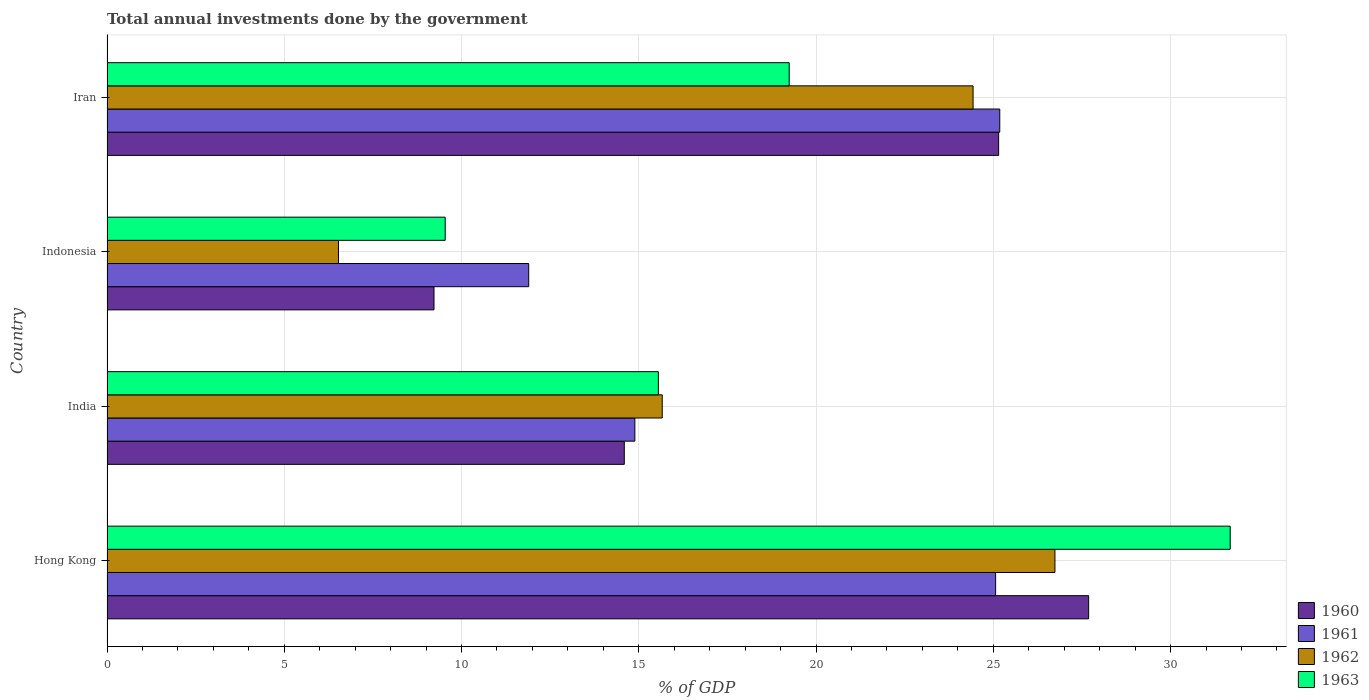How many different coloured bars are there?
Offer a very short reply. 4. How many bars are there on the 4th tick from the bottom?
Your answer should be very brief. 4. What is the label of the 1st group of bars from the top?
Offer a very short reply. Iran. In how many cases, is the number of bars for a given country not equal to the number of legend labels?
Your response must be concise. 0. What is the total annual investments done by the government in 1960 in Hong Kong?
Ensure brevity in your answer.  27.69. Across all countries, what is the maximum total annual investments done by the government in 1963?
Provide a succinct answer. 31.68. Across all countries, what is the minimum total annual investments done by the government in 1963?
Provide a succinct answer. 9.54. In which country was the total annual investments done by the government in 1960 maximum?
Your answer should be very brief. Hong Kong. What is the total total annual investments done by the government in 1961 in the graph?
Provide a short and direct response. 77.03. What is the difference between the total annual investments done by the government in 1963 in Indonesia and that in Iran?
Offer a terse response. -9.7. What is the difference between the total annual investments done by the government in 1963 in India and the total annual investments done by the government in 1961 in Indonesia?
Keep it short and to the point. 3.66. What is the average total annual investments done by the government in 1960 per country?
Provide a short and direct response. 19.16. What is the difference between the total annual investments done by the government in 1961 and total annual investments done by the government in 1962 in Hong Kong?
Make the answer very short. -1.67. In how many countries, is the total annual investments done by the government in 1963 greater than 3 %?
Make the answer very short. 4. What is the ratio of the total annual investments done by the government in 1963 in India to that in Iran?
Provide a short and direct response. 0.81. Is the total annual investments done by the government in 1960 in Hong Kong less than that in Iran?
Offer a terse response. No. Is the difference between the total annual investments done by the government in 1961 in Hong Kong and India greater than the difference between the total annual investments done by the government in 1962 in Hong Kong and India?
Make the answer very short. No. What is the difference between the highest and the second highest total annual investments done by the government in 1963?
Make the answer very short. 12.44. What is the difference between the highest and the lowest total annual investments done by the government in 1963?
Your answer should be compact. 22.14. Is it the case that in every country, the sum of the total annual investments done by the government in 1960 and total annual investments done by the government in 1961 is greater than the sum of total annual investments done by the government in 1963 and total annual investments done by the government in 1962?
Provide a short and direct response. No. What does the 3rd bar from the bottom in Indonesia represents?
Your response must be concise. 1962. Are all the bars in the graph horizontal?
Provide a succinct answer. Yes. How many countries are there in the graph?
Your answer should be very brief. 4. Are the values on the major ticks of X-axis written in scientific E-notation?
Provide a succinct answer. No. Does the graph contain any zero values?
Your answer should be very brief. No. Does the graph contain grids?
Offer a very short reply. Yes. How are the legend labels stacked?
Keep it short and to the point. Vertical. What is the title of the graph?
Provide a succinct answer. Total annual investments done by the government. Does "2000" appear as one of the legend labels in the graph?
Keep it short and to the point. No. What is the label or title of the X-axis?
Your answer should be very brief. % of GDP. What is the label or title of the Y-axis?
Make the answer very short. Country. What is the % of GDP in 1960 in Hong Kong?
Your answer should be very brief. 27.69. What is the % of GDP of 1961 in Hong Kong?
Make the answer very short. 25.06. What is the % of GDP in 1962 in Hong Kong?
Give a very brief answer. 26.74. What is the % of GDP of 1963 in Hong Kong?
Provide a succinct answer. 31.68. What is the % of GDP of 1960 in India?
Ensure brevity in your answer.  14.59. What is the % of GDP of 1961 in India?
Your answer should be compact. 14.89. What is the % of GDP of 1962 in India?
Offer a very short reply. 15.66. What is the % of GDP of 1963 in India?
Your response must be concise. 15.55. What is the % of GDP in 1960 in Indonesia?
Ensure brevity in your answer.  9.22. What is the % of GDP of 1961 in Indonesia?
Your answer should be very brief. 11.9. What is the % of GDP of 1962 in Indonesia?
Keep it short and to the point. 6.53. What is the % of GDP in 1963 in Indonesia?
Your answer should be very brief. 9.54. What is the % of GDP of 1960 in Iran?
Your response must be concise. 25.15. What is the % of GDP in 1961 in Iran?
Your response must be concise. 25.18. What is the % of GDP of 1962 in Iran?
Keep it short and to the point. 24.43. What is the % of GDP of 1963 in Iran?
Keep it short and to the point. 19.24. Across all countries, what is the maximum % of GDP in 1960?
Offer a very short reply. 27.69. Across all countries, what is the maximum % of GDP of 1961?
Offer a very short reply. 25.18. Across all countries, what is the maximum % of GDP of 1962?
Provide a short and direct response. 26.74. Across all countries, what is the maximum % of GDP of 1963?
Offer a terse response. 31.68. Across all countries, what is the minimum % of GDP of 1960?
Ensure brevity in your answer.  9.22. Across all countries, what is the minimum % of GDP of 1961?
Make the answer very short. 11.9. Across all countries, what is the minimum % of GDP in 1962?
Provide a succinct answer. 6.53. Across all countries, what is the minimum % of GDP in 1963?
Give a very brief answer. 9.54. What is the total % of GDP of 1960 in the graph?
Offer a very short reply. 76.65. What is the total % of GDP of 1961 in the graph?
Provide a succinct answer. 77.03. What is the total % of GDP of 1962 in the graph?
Your response must be concise. 73.36. What is the total % of GDP in 1963 in the graph?
Provide a succinct answer. 76.01. What is the difference between the % of GDP in 1960 in Hong Kong and that in India?
Provide a succinct answer. 13.1. What is the difference between the % of GDP in 1961 in Hong Kong and that in India?
Provide a short and direct response. 10.18. What is the difference between the % of GDP in 1962 in Hong Kong and that in India?
Provide a short and direct response. 11.08. What is the difference between the % of GDP of 1963 in Hong Kong and that in India?
Your response must be concise. 16.13. What is the difference between the % of GDP of 1960 in Hong Kong and that in Indonesia?
Offer a very short reply. 18.47. What is the difference between the % of GDP of 1961 in Hong Kong and that in Indonesia?
Keep it short and to the point. 13.17. What is the difference between the % of GDP of 1962 in Hong Kong and that in Indonesia?
Your response must be concise. 20.21. What is the difference between the % of GDP of 1963 in Hong Kong and that in Indonesia?
Your answer should be very brief. 22.14. What is the difference between the % of GDP in 1960 in Hong Kong and that in Iran?
Offer a very short reply. 2.54. What is the difference between the % of GDP of 1961 in Hong Kong and that in Iran?
Provide a succinct answer. -0.12. What is the difference between the % of GDP in 1962 in Hong Kong and that in Iran?
Offer a very short reply. 2.31. What is the difference between the % of GDP of 1963 in Hong Kong and that in Iran?
Your answer should be compact. 12.44. What is the difference between the % of GDP in 1960 in India and that in Indonesia?
Your response must be concise. 5.37. What is the difference between the % of GDP of 1961 in India and that in Indonesia?
Make the answer very short. 2.99. What is the difference between the % of GDP of 1962 in India and that in Indonesia?
Provide a succinct answer. 9.13. What is the difference between the % of GDP in 1963 in India and that in Indonesia?
Keep it short and to the point. 6.01. What is the difference between the % of GDP in 1960 in India and that in Iran?
Give a very brief answer. -10.56. What is the difference between the % of GDP in 1961 in India and that in Iran?
Ensure brevity in your answer.  -10.29. What is the difference between the % of GDP of 1962 in India and that in Iran?
Give a very brief answer. -8.77. What is the difference between the % of GDP of 1963 in India and that in Iran?
Offer a very short reply. -3.69. What is the difference between the % of GDP in 1960 in Indonesia and that in Iran?
Keep it short and to the point. -15.93. What is the difference between the % of GDP of 1961 in Indonesia and that in Iran?
Offer a very short reply. -13.29. What is the difference between the % of GDP of 1962 in Indonesia and that in Iran?
Ensure brevity in your answer.  -17.9. What is the difference between the % of GDP in 1963 in Indonesia and that in Iran?
Your answer should be very brief. -9.7. What is the difference between the % of GDP in 1960 in Hong Kong and the % of GDP in 1961 in India?
Ensure brevity in your answer.  12.8. What is the difference between the % of GDP of 1960 in Hong Kong and the % of GDP of 1962 in India?
Offer a terse response. 12.03. What is the difference between the % of GDP of 1960 in Hong Kong and the % of GDP of 1963 in India?
Offer a very short reply. 12.14. What is the difference between the % of GDP of 1961 in Hong Kong and the % of GDP of 1962 in India?
Your answer should be compact. 9.4. What is the difference between the % of GDP of 1961 in Hong Kong and the % of GDP of 1963 in India?
Ensure brevity in your answer.  9.51. What is the difference between the % of GDP of 1962 in Hong Kong and the % of GDP of 1963 in India?
Offer a terse response. 11.19. What is the difference between the % of GDP in 1960 in Hong Kong and the % of GDP in 1961 in Indonesia?
Your response must be concise. 15.79. What is the difference between the % of GDP of 1960 in Hong Kong and the % of GDP of 1962 in Indonesia?
Provide a short and direct response. 21.16. What is the difference between the % of GDP in 1960 in Hong Kong and the % of GDP in 1963 in Indonesia?
Your answer should be compact. 18.15. What is the difference between the % of GDP of 1961 in Hong Kong and the % of GDP of 1962 in Indonesia?
Your response must be concise. 18.54. What is the difference between the % of GDP in 1961 in Hong Kong and the % of GDP in 1963 in Indonesia?
Provide a succinct answer. 15.53. What is the difference between the % of GDP of 1962 in Hong Kong and the % of GDP of 1963 in Indonesia?
Offer a very short reply. 17.2. What is the difference between the % of GDP of 1960 in Hong Kong and the % of GDP of 1961 in Iran?
Offer a terse response. 2.51. What is the difference between the % of GDP in 1960 in Hong Kong and the % of GDP in 1962 in Iran?
Offer a terse response. 3.26. What is the difference between the % of GDP of 1960 in Hong Kong and the % of GDP of 1963 in Iran?
Give a very brief answer. 8.45. What is the difference between the % of GDP of 1961 in Hong Kong and the % of GDP of 1962 in Iran?
Provide a succinct answer. 0.64. What is the difference between the % of GDP of 1961 in Hong Kong and the % of GDP of 1963 in Iran?
Offer a very short reply. 5.82. What is the difference between the % of GDP in 1962 in Hong Kong and the % of GDP in 1963 in Iran?
Give a very brief answer. 7.5. What is the difference between the % of GDP in 1960 in India and the % of GDP in 1961 in Indonesia?
Offer a very short reply. 2.7. What is the difference between the % of GDP in 1960 in India and the % of GDP in 1962 in Indonesia?
Give a very brief answer. 8.06. What is the difference between the % of GDP in 1960 in India and the % of GDP in 1963 in Indonesia?
Give a very brief answer. 5.05. What is the difference between the % of GDP of 1961 in India and the % of GDP of 1962 in Indonesia?
Make the answer very short. 8.36. What is the difference between the % of GDP of 1961 in India and the % of GDP of 1963 in Indonesia?
Make the answer very short. 5.35. What is the difference between the % of GDP in 1962 in India and the % of GDP in 1963 in Indonesia?
Your answer should be compact. 6.12. What is the difference between the % of GDP of 1960 in India and the % of GDP of 1961 in Iran?
Make the answer very short. -10.59. What is the difference between the % of GDP in 1960 in India and the % of GDP in 1962 in Iran?
Offer a very short reply. -9.84. What is the difference between the % of GDP in 1960 in India and the % of GDP in 1963 in Iran?
Make the answer very short. -4.65. What is the difference between the % of GDP of 1961 in India and the % of GDP of 1962 in Iran?
Your answer should be compact. -9.54. What is the difference between the % of GDP of 1961 in India and the % of GDP of 1963 in Iran?
Provide a short and direct response. -4.35. What is the difference between the % of GDP in 1962 in India and the % of GDP in 1963 in Iran?
Your response must be concise. -3.58. What is the difference between the % of GDP in 1960 in Indonesia and the % of GDP in 1961 in Iran?
Make the answer very short. -15.96. What is the difference between the % of GDP in 1960 in Indonesia and the % of GDP in 1962 in Iran?
Offer a terse response. -15.21. What is the difference between the % of GDP in 1960 in Indonesia and the % of GDP in 1963 in Iran?
Keep it short and to the point. -10.02. What is the difference between the % of GDP of 1961 in Indonesia and the % of GDP of 1962 in Iran?
Give a very brief answer. -12.53. What is the difference between the % of GDP of 1961 in Indonesia and the % of GDP of 1963 in Iran?
Provide a succinct answer. -7.35. What is the difference between the % of GDP of 1962 in Indonesia and the % of GDP of 1963 in Iran?
Ensure brevity in your answer.  -12.71. What is the average % of GDP in 1960 per country?
Offer a very short reply. 19.16. What is the average % of GDP in 1961 per country?
Provide a short and direct response. 19.26. What is the average % of GDP in 1962 per country?
Give a very brief answer. 18.34. What is the average % of GDP in 1963 per country?
Offer a terse response. 19. What is the difference between the % of GDP of 1960 and % of GDP of 1961 in Hong Kong?
Your response must be concise. 2.62. What is the difference between the % of GDP in 1960 and % of GDP in 1962 in Hong Kong?
Keep it short and to the point. 0.95. What is the difference between the % of GDP in 1960 and % of GDP in 1963 in Hong Kong?
Give a very brief answer. -3.99. What is the difference between the % of GDP of 1961 and % of GDP of 1962 in Hong Kong?
Your answer should be compact. -1.67. What is the difference between the % of GDP of 1961 and % of GDP of 1963 in Hong Kong?
Give a very brief answer. -6.62. What is the difference between the % of GDP in 1962 and % of GDP in 1963 in Hong Kong?
Your response must be concise. -4.94. What is the difference between the % of GDP in 1960 and % of GDP in 1961 in India?
Make the answer very short. -0.3. What is the difference between the % of GDP of 1960 and % of GDP of 1962 in India?
Your answer should be compact. -1.07. What is the difference between the % of GDP in 1960 and % of GDP in 1963 in India?
Keep it short and to the point. -0.96. What is the difference between the % of GDP in 1961 and % of GDP in 1962 in India?
Keep it short and to the point. -0.77. What is the difference between the % of GDP in 1961 and % of GDP in 1963 in India?
Provide a succinct answer. -0.66. What is the difference between the % of GDP in 1962 and % of GDP in 1963 in India?
Your response must be concise. 0.11. What is the difference between the % of GDP in 1960 and % of GDP in 1961 in Indonesia?
Give a very brief answer. -2.67. What is the difference between the % of GDP in 1960 and % of GDP in 1962 in Indonesia?
Your response must be concise. 2.69. What is the difference between the % of GDP of 1960 and % of GDP of 1963 in Indonesia?
Ensure brevity in your answer.  -0.32. What is the difference between the % of GDP in 1961 and % of GDP in 1962 in Indonesia?
Keep it short and to the point. 5.37. What is the difference between the % of GDP in 1961 and % of GDP in 1963 in Indonesia?
Offer a very short reply. 2.36. What is the difference between the % of GDP in 1962 and % of GDP in 1963 in Indonesia?
Your answer should be compact. -3.01. What is the difference between the % of GDP in 1960 and % of GDP in 1961 in Iran?
Keep it short and to the point. -0.03. What is the difference between the % of GDP in 1960 and % of GDP in 1962 in Iran?
Your response must be concise. 0.72. What is the difference between the % of GDP of 1960 and % of GDP of 1963 in Iran?
Make the answer very short. 5.91. What is the difference between the % of GDP in 1961 and % of GDP in 1962 in Iran?
Your answer should be very brief. 0.75. What is the difference between the % of GDP of 1961 and % of GDP of 1963 in Iran?
Offer a very short reply. 5.94. What is the difference between the % of GDP in 1962 and % of GDP in 1963 in Iran?
Give a very brief answer. 5.19. What is the ratio of the % of GDP in 1960 in Hong Kong to that in India?
Provide a succinct answer. 1.9. What is the ratio of the % of GDP of 1961 in Hong Kong to that in India?
Your response must be concise. 1.68. What is the ratio of the % of GDP in 1962 in Hong Kong to that in India?
Keep it short and to the point. 1.71. What is the ratio of the % of GDP in 1963 in Hong Kong to that in India?
Your answer should be very brief. 2.04. What is the ratio of the % of GDP in 1960 in Hong Kong to that in Indonesia?
Make the answer very short. 3. What is the ratio of the % of GDP in 1961 in Hong Kong to that in Indonesia?
Your answer should be very brief. 2.11. What is the ratio of the % of GDP in 1962 in Hong Kong to that in Indonesia?
Your answer should be compact. 4.09. What is the ratio of the % of GDP of 1963 in Hong Kong to that in Indonesia?
Your response must be concise. 3.32. What is the ratio of the % of GDP of 1960 in Hong Kong to that in Iran?
Ensure brevity in your answer.  1.1. What is the ratio of the % of GDP in 1961 in Hong Kong to that in Iran?
Provide a succinct answer. 1. What is the ratio of the % of GDP in 1962 in Hong Kong to that in Iran?
Your answer should be compact. 1.09. What is the ratio of the % of GDP in 1963 in Hong Kong to that in Iran?
Your answer should be very brief. 1.65. What is the ratio of the % of GDP in 1960 in India to that in Indonesia?
Make the answer very short. 1.58. What is the ratio of the % of GDP of 1961 in India to that in Indonesia?
Offer a terse response. 1.25. What is the ratio of the % of GDP of 1962 in India to that in Indonesia?
Offer a very short reply. 2.4. What is the ratio of the % of GDP of 1963 in India to that in Indonesia?
Offer a terse response. 1.63. What is the ratio of the % of GDP in 1960 in India to that in Iran?
Provide a succinct answer. 0.58. What is the ratio of the % of GDP of 1961 in India to that in Iran?
Make the answer very short. 0.59. What is the ratio of the % of GDP of 1962 in India to that in Iran?
Provide a succinct answer. 0.64. What is the ratio of the % of GDP in 1963 in India to that in Iran?
Your answer should be compact. 0.81. What is the ratio of the % of GDP of 1960 in Indonesia to that in Iran?
Your answer should be compact. 0.37. What is the ratio of the % of GDP of 1961 in Indonesia to that in Iran?
Your answer should be very brief. 0.47. What is the ratio of the % of GDP in 1962 in Indonesia to that in Iran?
Keep it short and to the point. 0.27. What is the ratio of the % of GDP in 1963 in Indonesia to that in Iran?
Offer a very short reply. 0.5. What is the difference between the highest and the second highest % of GDP in 1960?
Keep it short and to the point. 2.54. What is the difference between the highest and the second highest % of GDP of 1961?
Make the answer very short. 0.12. What is the difference between the highest and the second highest % of GDP of 1962?
Your response must be concise. 2.31. What is the difference between the highest and the second highest % of GDP in 1963?
Ensure brevity in your answer.  12.44. What is the difference between the highest and the lowest % of GDP of 1960?
Your answer should be very brief. 18.47. What is the difference between the highest and the lowest % of GDP of 1961?
Provide a short and direct response. 13.29. What is the difference between the highest and the lowest % of GDP in 1962?
Your answer should be very brief. 20.21. What is the difference between the highest and the lowest % of GDP in 1963?
Give a very brief answer. 22.14. 